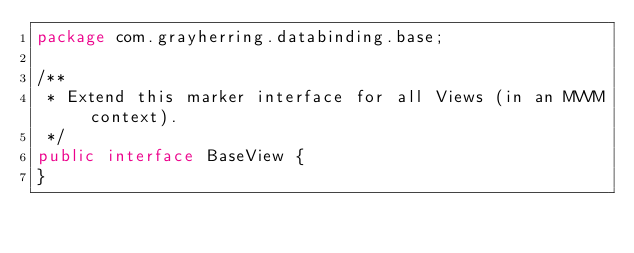Convert code to text. <code><loc_0><loc_0><loc_500><loc_500><_Java_>package com.grayherring.databinding.base;

/**
 * Extend this marker interface for all Views (in an MVVM context).
 */
public interface BaseView {
}
</code> 